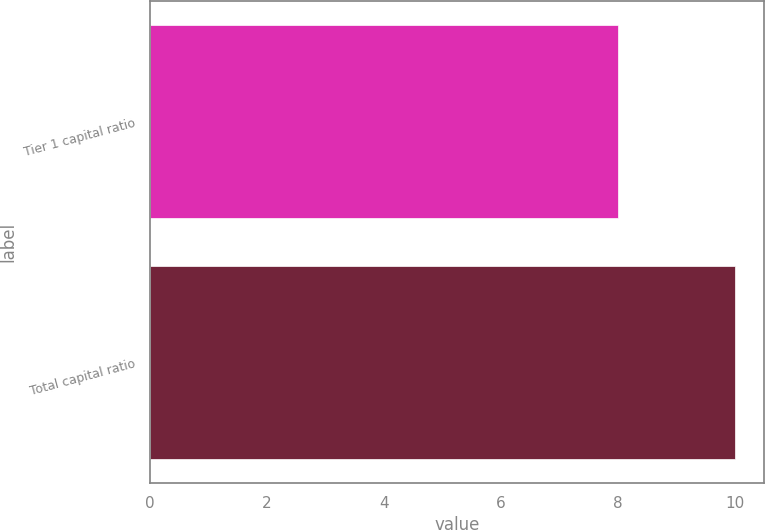Convert chart to OTSL. <chart><loc_0><loc_0><loc_500><loc_500><bar_chart><fcel>Tier 1 capital ratio<fcel>Total capital ratio<nl><fcel>8<fcel>10<nl></chart> 